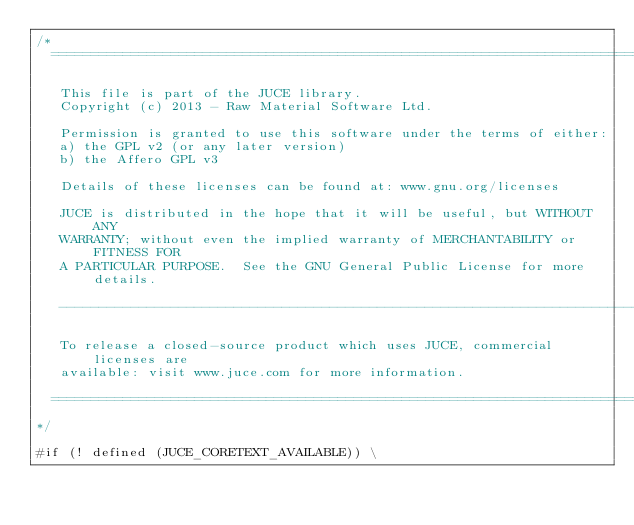Convert code to text. <code><loc_0><loc_0><loc_500><loc_500><_ObjectiveC_>/*
  ==============================================================================

   This file is part of the JUCE library.
   Copyright (c) 2013 - Raw Material Software Ltd.

   Permission is granted to use this software under the terms of either:
   a) the GPL v2 (or any later version)
   b) the Affero GPL v3

   Details of these licenses can be found at: www.gnu.org/licenses

   JUCE is distributed in the hope that it will be useful, but WITHOUT ANY
   WARRANTY; without even the implied warranty of MERCHANTABILITY or FITNESS FOR
   A PARTICULAR PURPOSE.  See the GNU General Public License for more details.

   ------------------------------------------------------------------------------

   To release a closed-source product which uses JUCE, commercial licenses are
   available: visit www.juce.com for more information.

  ==============================================================================
*/

#if (! defined (JUCE_CORETEXT_AVAILABLE)) \</code> 